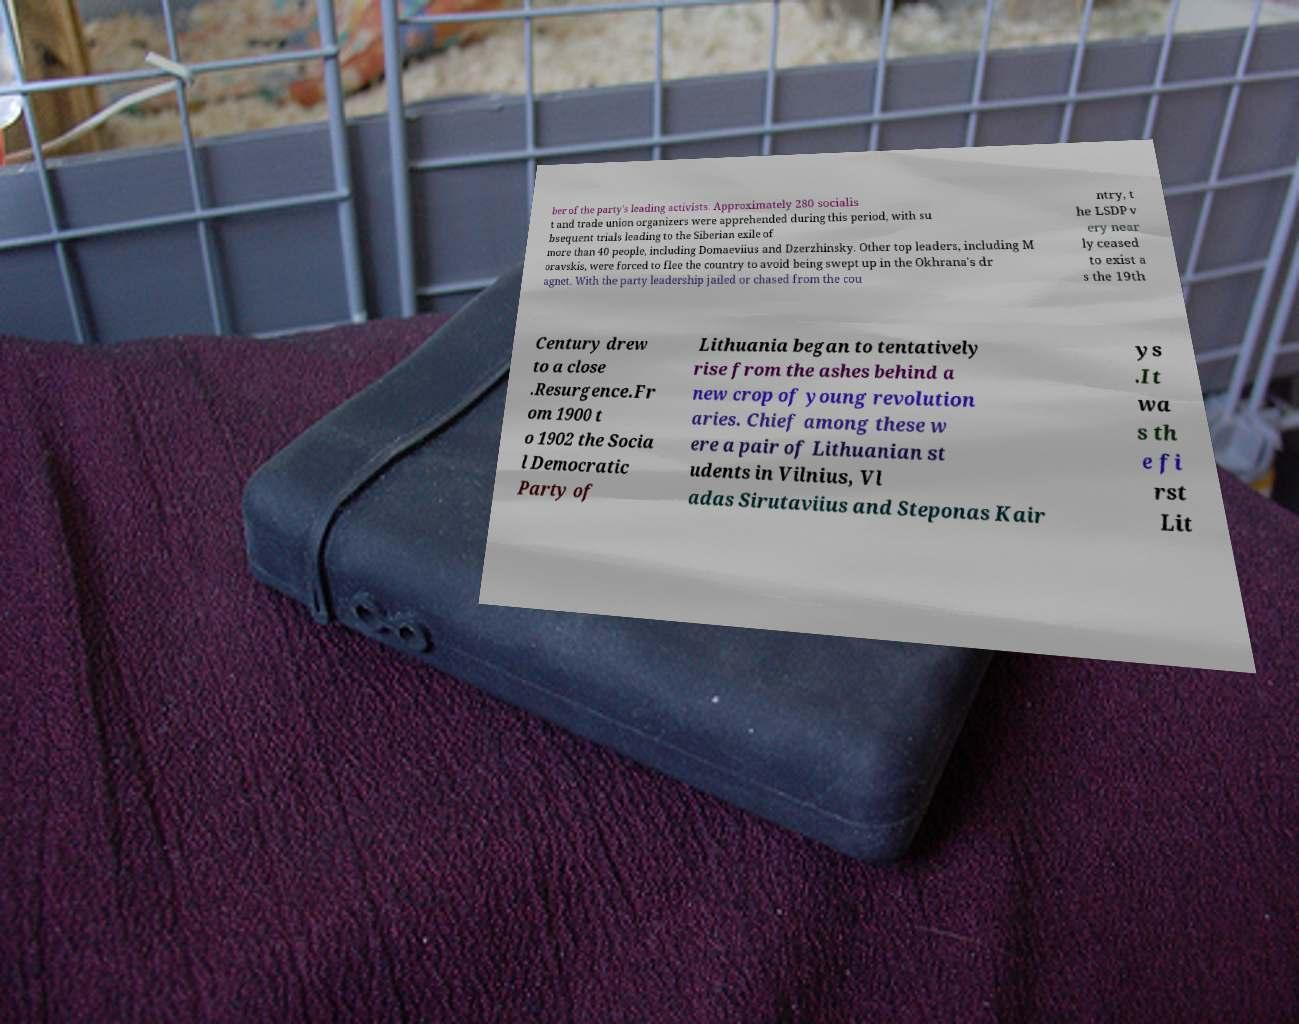Could you extract and type out the text from this image? ber of the party's leading activists. Approximately 280 socialis t and trade union organizers were apprehended during this period, with su bsequent trials leading to the Siberian exile of more than 40 people, including Domaeviius and Dzerzhinsky. Other top leaders, including M oravskis, were forced to flee the country to avoid being swept up in the Okhrana's dr agnet. With the party leadership jailed or chased from the cou ntry, t he LSDP v ery near ly ceased to exist a s the 19th Century drew to a close .Resurgence.Fr om 1900 t o 1902 the Socia l Democratic Party of Lithuania began to tentatively rise from the ashes behind a new crop of young revolution aries. Chief among these w ere a pair of Lithuanian st udents in Vilnius, Vl adas Sirutaviius and Steponas Kair ys .It wa s th e fi rst Lit 